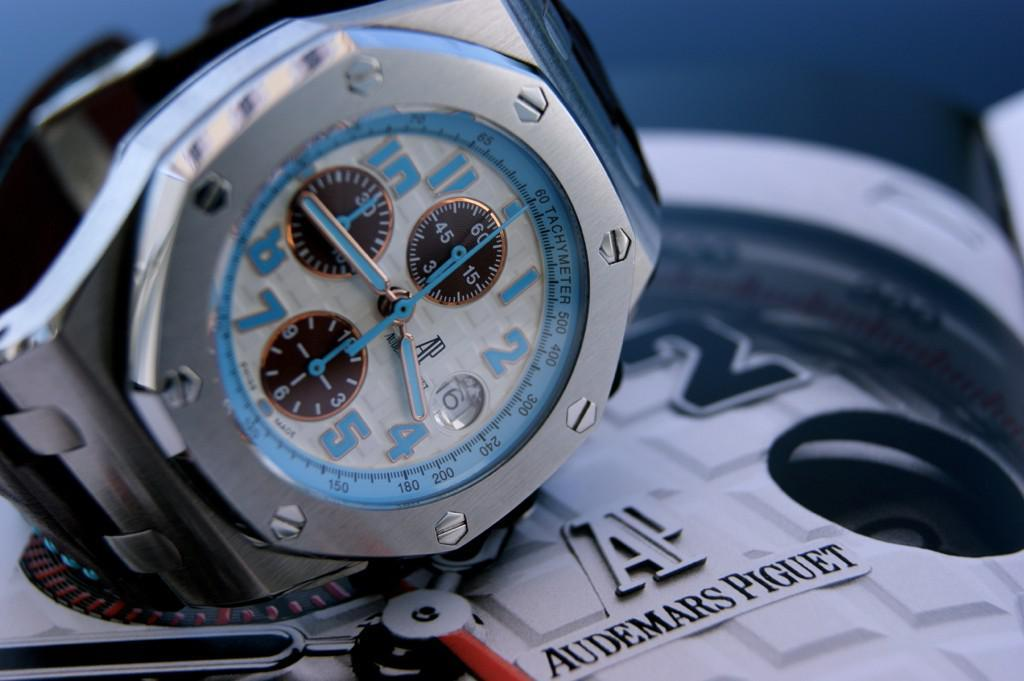<image>
Provide a brief description of the given image. A watch with Audemars Piguet written next to it. 